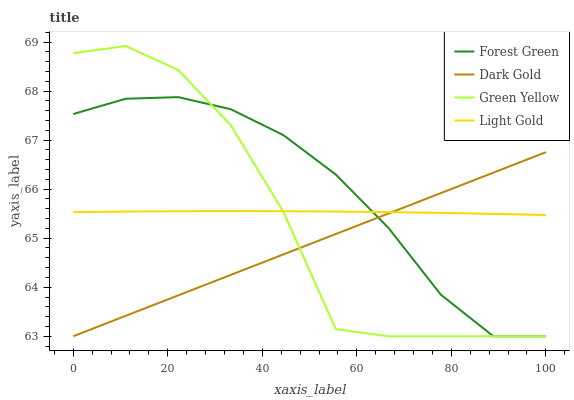Does Dark Gold have the minimum area under the curve?
Answer yes or no. Yes. Does Forest Green have the maximum area under the curve?
Answer yes or no. Yes. Does Green Yellow have the minimum area under the curve?
Answer yes or no. No. Does Green Yellow have the maximum area under the curve?
Answer yes or no. No. Is Dark Gold the smoothest?
Answer yes or no. Yes. Is Green Yellow the roughest?
Answer yes or no. Yes. Is Light Gold the smoothest?
Answer yes or no. No. Is Light Gold the roughest?
Answer yes or no. No. Does Light Gold have the lowest value?
Answer yes or no. No. Does Green Yellow have the highest value?
Answer yes or no. Yes. Does Light Gold have the highest value?
Answer yes or no. No. Does Forest Green intersect Green Yellow?
Answer yes or no. Yes. Is Forest Green less than Green Yellow?
Answer yes or no. No. Is Forest Green greater than Green Yellow?
Answer yes or no. No. 